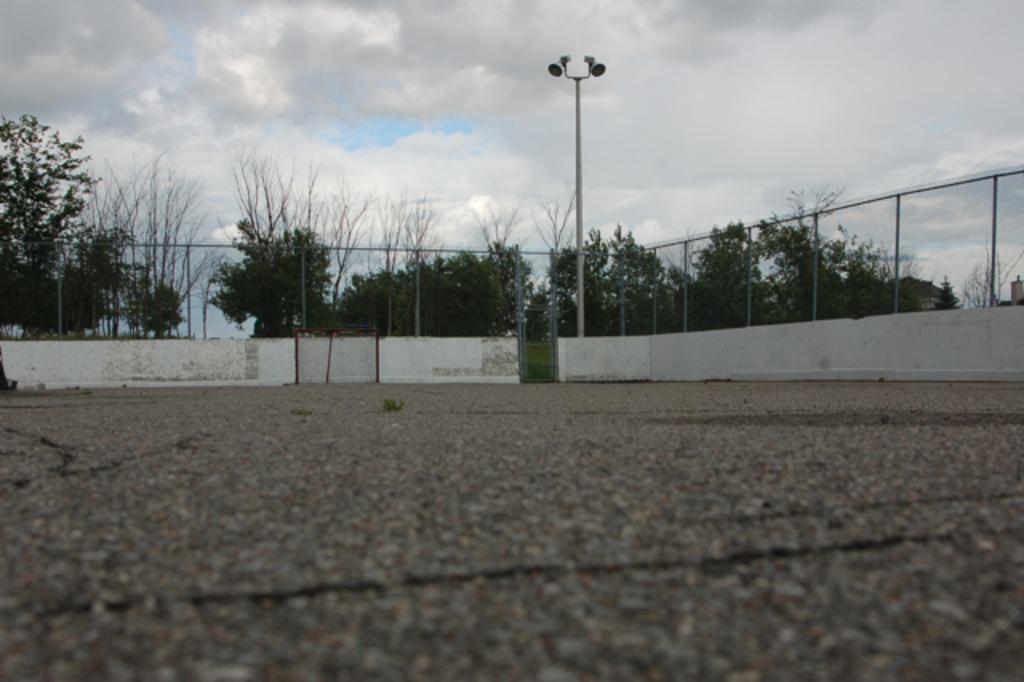How would you summarize this image in a sentence or two? In this image at the bottom there is a road and in the center there are some trees fence, wall and pole and some lights. At the top of the image there is sky. 